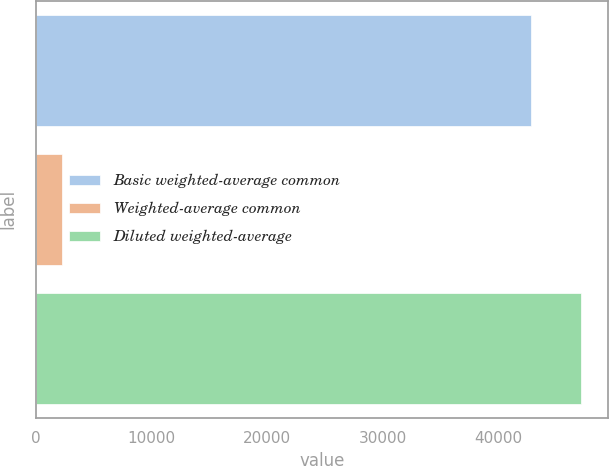<chart> <loc_0><loc_0><loc_500><loc_500><bar_chart><fcel>Basic weighted-average common<fcel>Weighted-average common<fcel>Diluted weighted-average<nl><fcel>42824<fcel>2302<fcel>47106.4<nl></chart> 